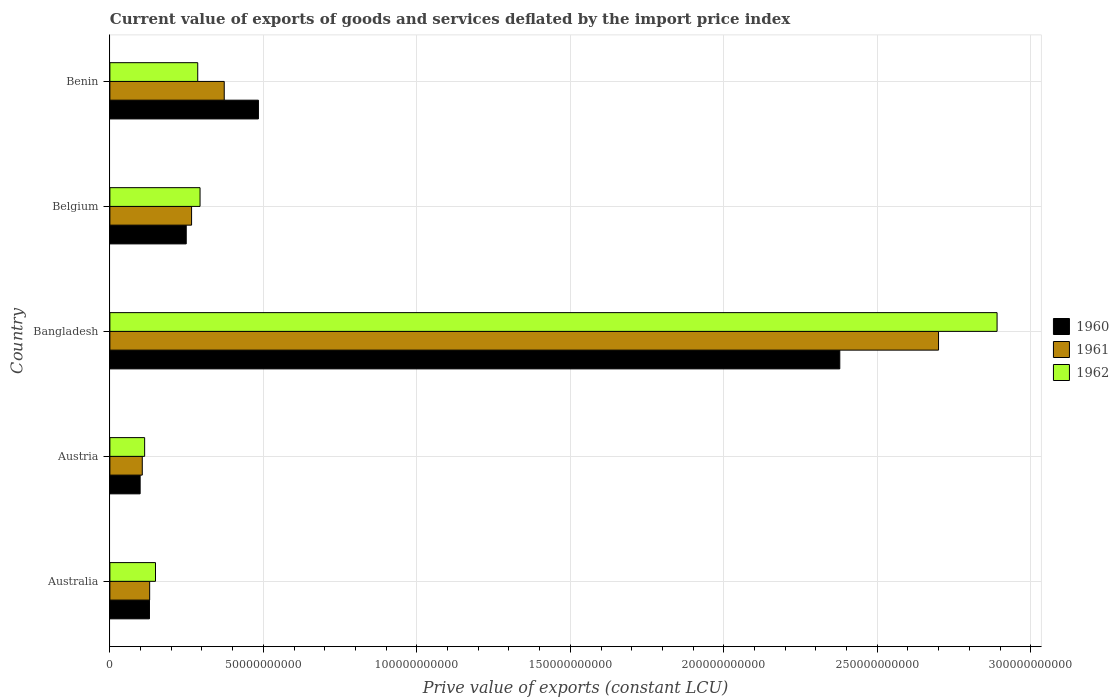How many bars are there on the 4th tick from the top?
Keep it short and to the point. 3. What is the label of the 1st group of bars from the top?
Make the answer very short. Benin. In how many cases, is the number of bars for a given country not equal to the number of legend labels?
Offer a terse response. 0. What is the prive value of exports in 1960 in Benin?
Your answer should be compact. 4.84e+1. Across all countries, what is the maximum prive value of exports in 1961?
Make the answer very short. 2.70e+11. Across all countries, what is the minimum prive value of exports in 1960?
Your response must be concise. 9.86e+09. In which country was the prive value of exports in 1961 minimum?
Provide a short and direct response. Austria. What is the total prive value of exports in 1960 in the graph?
Provide a succinct answer. 3.34e+11. What is the difference between the prive value of exports in 1961 in Austria and that in Bangladesh?
Your answer should be very brief. -2.59e+11. What is the difference between the prive value of exports in 1962 in Benin and the prive value of exports in 1960 in Belgium?
Your answer should be compact. 3.75e+09. What is the average prive value of exports in 1961 per country?
Give a very brief answer. 7.15e+1. What is the difference between the prive value of exports in 1962 and prive value of exports in 1961 in Belgium?
Your answer should be very brief. 2.76e+09. In how many countries, is the prive value of exports in 1960 greater than 70000000000 LCU?
Keep it short and to the point. 1. What is the ratio of the prive value of exports in 1960 in Bangladesh to that in Benin?
Offer a terse response. 4.91. Is the difference between the prive value of exports in 1962 in Austria and Bangladesh greater than the difference between the prive value of exports in 1961 in Austria and Bangladesh?
Provide a short and direct response. No. What is the difference between the highest and the second highest prive value of exports in 1960?
Offer a very short reply. 1.89e+11. What is the difference between the highest and the lowest prive value of exports in 1962?
Provide a succinct answer. 2.78e+11. What does the 1st bar from the bottom in Belgium represents?
Offer a terse response. 1960. Is it the case that in every country, the sum of the prive value of exports in 1960 and prive value of exports in 1962 is greater than the prive value of exports in 1961?
Keep it short and to the point. Yes. How many bars are there?
Your answer should be compact. 15. How many countries are there in the graph?
Offer a terse response. 5. Are the values on the major ticks of X-axis written in scientific E-notation?
Provide a succinct answer. No. Does the graph contain any zero values?
Make the answer very short. No. Where does the legend appear in the graph?
Provide a succinct answer. Center right. What is the title of the graph?
Offer a terse response. Current value of exports of goods and services deflated by the import price index. What is the label or title of the X-axis?
Make the answer very short. Prive value of exports (constant LCU). What is the Prive value of exports (constant LCU) of 1960 in Australia?
Your answer should be compact. 1.29e+1. What is the Prive value of exports (constant LCU) of 1961 in Australia?
Ensure brevity in your answer.  1.30e+1. What is the Prive value of exports (constant LCU) of 1962 in Australia?
Keep it short and to the point. 1.49e+1. What is the Prive value of exports (constant LCU) in 1960 in Austria?
Keep it short and to the point. 9.86e+09. What is the Prive value of exports (constant LCU) in 1961 in Austria?
Provide a succinct answer. 1.06e+1. What is the Prive value of exports (constant LCU) of 1962 in Austria?
Give a very brief answer. 1.13e+1. What is the Prive value of exports (constant LCU) of 1960 in Bangladesh?
Keep it short and to the point. 2.38e+11. What is the Prive value of exports (constant LCU) of 1961 in Bangladesh?
Give a very brief answer. 2.70e+11. What is the Prive value of exports (constant LCU) of 1962 in Bangladesh?
Provide a succinct answer. 2.89e+11. What is the Prive value of exports (constant LCU) of 1960 in Belgium?
Your answer should be compact. 2.49e+1. What is the Prive value of exports (constant LCU) of 1961 in Belgium?
Your response must be concise. 2.66e+1. What is the Prive value of exports (constant LCU) in 1962 in Belgium?
Keep it short and to the point. 2.94e+1. What is the Prive value of exports (constant LCU) in 1960 in Benin?
Your answer should be very brief. 4.84e+1. What is the Prive value of exports (constant LCU) of 1961 in Benin?
Provide a succinct answer. 3.73e+1. What is the Prive value of exports (constant LCU) in 1962 in Benin?
Give a very brief answer. 2.86e+1. Across all countries, what is the maximum Prive value of exports (constant LCU) in 1960?
Give a very brief answer. 2.38e+11. Across all countries, what is the maximum Prive value of exports (constant LCU) in 1961?
Your answer should be compact. 2.70e+11. Across all countries, what is the maximum Prive value of exports (constant LCU) of 1962?
Give a very brief answer. 2.89e+11. Across all countries, what is the minimum Prive value of exports (constant LCU) of 1960?
Keep it short and to the point. 9.86e+09. Across all countries, what is the minimum Prive value of exports (constant LCU) in 1961?
Give a very brief answer. 1.06e+1. Across all countries, what is the minimum Prive value of exports (constant LCU) of 1962?
Your answer should be very brief. 1.13e+1. What is the total Prive value of exports (constant LCU) in 1960 in the graph?
Offer a very short reply. 3.34e+11. What is the total Prive value of exports (constant LCU) of 1961 in the graph?
Make the answer very short. 3.57e+11. What is the total Prive value of exports (constant LCU) of 1962 in the graph?
Ensure brevity in your answer.  3.73e+11. What is the difference between the Prive value of exports (constant LCU) in 1960 in Australia and that in Austria?
Provide a short and direct response. 3.04e+09. What is the difference between the Prive value of exports (constant LCU) in 1961 in Australia and that in Austria?
Give a very brief answer. 2.41e+09. What is the difference between the Prive value of exports (constant LCU) in 1962 in Australia and that in Austria?
Provide a succinct answer. 3.54e+09. What is the difference between the Prive value of exports (constant LCU) in 1960 in Australia and that in Bangladesh?
Give a very brief answer. -2.25e+11. What is the difference between the Prive value of exports (constant LCU) in 1961 in Australia and that in Bangladesh?
Your answer should be very brief. -2.57e+11. What is the difference between the Prive value of exports (constant LCU) in 1962 in Australia and that in Bangladesh?
Give a very brief answer. -2.74e+11. What is the difference between the Prive value of exports (constant LCU) of 1960 in Australia and that in Belgium?
Provide a short and direct response. -1.20e+1. What is the difference between the Prive value of exports (constant LCU) in 1961 in Australia and that in Belgium?
Provide a succinct answer. -1.37e+1. What is the difference between the Prive value of exports (constant LCU) of 1962 in Australia and that in Belgium?
Offer a terse response. -1.45e+1. What is the difference between the Prive value of exports (constant LCU) in 1960 in Australia and that in Benin?
Offer a terse response. -3.55e+1. What is the difference between the Prive value of exports (constant LCU) of 1961 in Australia and that in Benin?
Offer a terse response. -2.43e+1. What is the difference between the Prive value of exports (constant LCU) in 1962 in Australia and that in Benin?
Make the answer very short. -1.38e+1. What is the difference between the Prive value of exports (constant LCU) of 1960 in Austria and that in Bangladesh?
Ensure brevity in your answer.  -2.28e+11. What is the difference between the Prive value of exports (constant LCU) in 1961 in Austria and that in Bangladesh?
Your response must be concise. -2.59e+11. What is the difference between the Prive value of exports (constant LCU) in 1962 in Austria and that in Bangladesh?
Your response must be concise. -2.78e+11. What is the difference between the Prive value of exports (constant LCU) of 1960 in Austria and that in Belgium?
Provide a succinct answer. -1.50e+1. What is the difference between the Prive value of exports (constant LCU) of 1961 in Austria and that in Belgium?
Give a very brief answer. -1.61e+1. What is the difference between the Prive value of exports (constant LCU) of 1962 in Austria and that in Belgium?
Your answer should be compact. -1.81e+1. What is the difference between the Prive value of exports (constant LCU) of 1960 in Austria and that in Benin?
Give a very brief answer. -3.85e+1. What is the difference between the Prive value of exports (constant LCU) of 1961 in Austria and that in Benin?
Ensure brevity in your answer.  -2.67e+1. What is the difference between the Prive value of exports (constant LCU) in 1962 in Austria and that in Benin?
Offer a terse response. -1.73e+1. What is the difference between the Prive value of exports (constant LCU) in 1960 in Bangladesh and that in Belgium?
Provide a succinct answer. 2.13e+11. What is the difference between the Prive value of exports (constant LCU) of 1961 in Bangladesh and that in Belgium?
Your answer should be compact. 2.43e+11. What is the difference between the Prive value of exports (constant LCU) of 1962 in Bangladesh and that in Belgium?
Your answer should be very brief. 2.60e+11. What is the difference between the Prive value of exports (constant LCU) of 1960 in Bangladesh and that in Benin?
Provide a short and direct response. 1.89e+11. What is the difference between the Prive value of exports (constant LCU) in 1961 in Bangladesh and that in Benin?
Provide a short and direct response. 2.33e+11. What is the difference between the Prive value of exports (constant LCU) in 1962 in Bangladesh and that in Benin?
Ensure brevity in your answer.  2.60e+11. What is the difference between the Prive value of exports (constant LCU) of 1960 in Belgium and that in Benin?
Provide a short and direct response. -2.35e+1. What is the difference between the Prive value of exports (constant LCU) in 1961 in Belgium and that in Benin?
Your answer should be very brief. -1.06e+1. What is the difference between the Prive value of exports (constant LCU) of 1962 in Belgium and that in Benin?
Give a very brief answer. 7.58e+08. What is the difference between the Prive value of exports (constant LCU) in 1960 in Australia and the Prive value of exports (constant LCU) in 1961 in Austria?
Offer a terse response. 2.34e+09. What is the difference between the Prive value of exports (constant LCU) of 1960 in Australia and the Prive value of exports (constant LCU) of 1962 in Austria?
Your answer should be compact. 1.57e+09. What is the difference between the Prive value of exports (constant LCU) in 1961 in Australia and the Prive value of exports (constant LCU) in 1962 in Austria?
Offer a very short reply. 1.64e+09. What is the difference between the Prive value of exports (constant LCU) in 1960 in Australia and the Prive value of exports (constant LCU) in 1961 in Bangladesh?
Keep it short and to the point. -2.57e+11. What is the difference between the Prive value of exports (constant LCU) of 1960 in Australia and the Prive value of exports (constant LCU) of 1962 in Bangladesh?
Ensure brevity in your answer.  -2.76e+11. What is the difference between the Prive value of exports (constant LCU) of 1961 in Australia and the Prive value of exports (constant LCU) of 1962 in Bangladesh?
Give a very brief answer. -2.76e+11. What is the difference between the Prive value of exports (constant LCU) of 1960 in Australia and the Prive value of exports (constant LCU) of 1961 in Belgium?
Your response must be concise. -1.37e+1. What is the difference between the Prive value of exports (constant LCU) of 1960 in Australia and the Prive value of exports (constant LCU) of 1962 in Belgium?
Give a very brief answer. -1.65e+1. What is the difference between the Prive value of exports (constant LCU) of 1961 in Australia and the Prive value of exports (constant LCU) of 1962 in Belgium?
Your response must be concise. -1.64e+1. What is the difference between the Prive value of exports (constant LCU) in 1960 in Australia and the Prive value of exports (constant LCU) in 1961 in Benin?
Your response must be concise. -2.44e+1. What is the difference between the Prive value of exports (constant LCU) in 1960 in Australia and the Prive value of exports (constant LCU) in 1962 in Benin?
Keep it short and to the point. -1.57e+1. What is the difference between the Prive value of exports (constant LCU) in 1961 in Australia and the Prive value of exports (constant LCU) in 1962 in Benin?
Your answer should be compact. -1.57e+1. What is the difference between the Prive value of exports (constant LCU) in 1960 in Austria and the Prive value of exports (constant LCU) in 1961 in Bangladesh?
Offer a very short reply. -2.60e+11. What is the difference between the Prive value of exports (constant LCU) in 1960 in Austria and the Prive value of exports (constant LCU) in 1962 in Bangladesh?
Give a very brief answer. -2.79e+11. What is the difference between the Prive value of exports (constant LCU) of 1961 in Austria and the Prive value of exports (constant LCU) of 1962 in Bangladesh?
Keep it short and to the point. -2.78e+11. What is the difference between the Prive value of exports (constant LCU) in 1960 in Austria and the Prive value of exports (constant LCU) in 1961 in Belgium?
Your answer should be compact. -1.68e+1. What is the difference between the Prive value of exports (constant LCU) of 1960 in Austria and the Prive value of exports (constant LCU) of 1962 in Belgium?
Provide a succinct answer. -1.95e+1. What is the difference between the Prive value of exports (constant LCU) in 1961 in Austria and the Prive value of exports (constant LCU) in 1962 in Belgium?
Your answer should be very brief. -1.88e+1. What is the difference between the Prive value of exports (constant LCU) of 1960 in Austria and the Prive value of exports (constant LCU) of 1961 in Benin?
Your answer should be very brief. -2.74e+1. What is the difference between the Prive value of exports (constant LCU) of 1960 in Austria and the Prive value of exports (constant LCU) of 1962 in Benin?
Offer a very short reply. -1.88e+1. What is the difference between the Prive value of exports (constant LCU) of 1961 in Austria and the Prive value of exports (constant LCU) of 1962 in Benin?
Provide a succinct answer. -1.81e+1. What is the difference between the Prive value of exports (constant LCU) in 1960 in Bangladesh and the Prive value of exports (constant LCU) in 1961 in Belgium?
Your response must be concise. 2.11e+11. What is the difference between the Prive value of exports (constant LCU) in 1960 in Bangladesh and the Prive value of exports (constant LCU) in 1962 in Belgium?
Keep it short and to the point. 2.08e+11. What is the difference between the Prive value of exports (constant LCU) of 1961 in Bangladesh and the Prive value of exports (constant LCU) of 1962 in Belgium?
Give a very brief answer. 2.41e+11. What is the difference between the Prive value of exports (constant LCU) in 1960 in Bangladesh and the Prive value of exports (constant LCU) in 1961 in Benin?
Keep it short and to the point. 2.01e+11. What is the difference between the Prive value of exports (constant LCU) of 1960 in Bangladesh and the Prive value of exports (constant LCU) of 1962 in Benin?
Provide a short and direct response. 2.09e+11. What is the difference between the Prive value of exports (constant LCU) of 1961 in Bangladesh and the Prive value of exports (constant LCU) of 1962 in Benin?
Your answer should be very brief. 2.41e+11. What is the difference between the Prive value of exports (constant LCU) in 1960 in Belgium and the Prive value of exports (constant LCU) in 1961 in Benin?
Your response must be concise. -1.24e+1. What is the difference between the Prive value of exports (constant LCU) of 1960 in Belgium and the Prive value of exports (constant LCU) of 1962 in Benin?
Provide a succinct answer. -3.75e+09. What is the difference between the Prive value of exports (constant LCU) of 1961 in Belgium and the Prive value of exports (constant LCU) of 1962 in Benin?
Offer a very short reply. -2.00e+09. What is the average Prive value of exports (constant LCU) in 1960 per country?
Provide a succinct answer. 6.68e+1. What is the average Prive value of exports (constant LCU) of 1961 per country?
Offer a terse response. 7.15e+1. What is the average Prive value of exports (constant LCU) of 1962 per country?
Your response must be concise. 7.46e+1. What is the difference between the Prive value of exports (constant LCU) in 1960 and Prive value of exports (constant LCU) in 1961 in Australia?
Offer a terse response. -6.58e+07. What is the difference between the Prive value of exports (constant LCU) of 1960 and Prive value of exports (constant LCU) of 1962 in Australia?
Give a very brief answer. -1.96e+09. What is the difference between the Prive value of exports (constant LCU) in 1961 and Prive value of exports (constant LCU) in 1962 in Australia?
Your response must be concise. -1.90e+09. What is the difference between the Prive value of exports (constant LCU) of 1960 and Prive value of exports (constant LCU) of 1961 in Austria?
Provide a succinct answer. -6.95e+08. What is the difference between the Prive value of exports (constant LCU) in 1960 and Prive value of exports (constant LCU) in 1962 in Austria?
Provide a succinct answer. -1.46e+09. What is the difference between the Prive value of exports (constant LCU) in 1961 and Prive value of exports (constant LCU) in 1962 in Austria?
Your answer should be compact. -7.67e+08. What is the difference between the Prive value of exports (constant LCU) of 1960 and Prive value of exports (constant LCU) of 1961 in Bangladesh?
Your response must be concise. -3.22e+1. What is the difference between the Prive value of exports (constant LCU) of 1960 and Prive value of exports (constant LCU) of 1962 in Bangladesh?
Provide a short and direct response. -5.12e+1. What is the difference between the Prive value of exports (constant LCU) of 1961 and Prive value of exports (constant LCU) of 1962 in Bangladesh?
Your response must be concise. -1.91e+1. What is the difference between the Prive value of exports (constant LCU) of 1960 and Prive value of exports (constant LCU) of 1961 in Belgium?
Keep it short and to the point. -1.74e+09. What is the difference between the Prive value of exports (constant LCU) in 1960 and Prive value of exports (constant LCU) in 1962 in Belgium?
Provide a short and direct response. -4.50e+09. What is the difference between the Prive value of exports (constant LCU) in 1961 and Prive value of exports (constant LCU) in 1962 in Belgium?
Make the answer very short. -2.76e+09. What is the difference between the Prive value of exports (constant LCU) of 1960 and Prive value of exports (constant LCU) of 1961 in Benin?
Provide a succinct answer. 1.11e+1. What is the difference between the Prive value of exports (constant LCU) of 1960 and Prive value of exports (constant LCU) of 1962 in Benin?
Your answer should be compact. 1.98e+1. What is the difference between the Prive value of exports (constant LCU) in 1961 and Prive value of exports (constant LCU) in 1962 in Benin?
Your answer should be very brief. 8.64e+09. What is the ratio of the Prive value of exports (constant LCU) in 1960 in Australia to that in Austria?
Your answer should be compact. 1.31. What is the ratio of the Prive value of exports (constant LCU) of 1961 in Australia to that in Austria?
Your response must be concise. 1.23. What is the ratio of the Prive value of exports (constant LCU) in 1962 in Australia to that in Austria?
Offer a very short reply. 1.31. What is the ratio of the Prive value of exports (constant LCU) of 1960 in Australia to that in Bangladesh?
Your answer should be very brief. 0.05. What is the ratio of the Prive value of exports (constant LCU) of 1961 in Australia to that in Bangladesh?
Provide a succinct answer. 0.05. What is the ratio of the Prive value of exports (constant LCU) in 1962 in Australia to that in Bangladesh?
Offer a terse response. 0.05. What is the ratio of the Prive value of exports (constant LCU) in 1960 in Australia to that in Belgium?
Provide a succinct answer. 0.52. What is the ratio of the Prive value of exports (constant LCU) in 1961 in Australia to that in Belgium?
Your answer should be compact. 0.49. What is the ratio of the Prive value of exports (constant LCU) in 1962 in Australia to that in Belgium?
Give a very brief answer. 0.51. What is the ratio of the Prive value of exports (constant LCU) in 1960 in Australia to that in Benin?
Offer a very short reply. 0.27. What is the ratio of the Prive value of exports (constant LCU) in 1961 in Australia to that in Benin?
Provide a short and direct response. 0.35. What is the ratio of the Prive value of exports (constant LCU) in 1962 in Australia to that in Benin?
Give a very brief answer. 0.52. What is the ratio of the Prive value of exports (constant LCU) of 1960 in Austria to that in Bangladesh?
Make the answer very short. 0.04. What is the ratio of the Prive value of exports (constant LCU) in 1961 in Austria to that in Bangladesh?
Give a very brief answer. 0.04. What is the ratio of the Prive value of exports (constant LCU) of 1962 in Austria to that in Bangladesh?
Provide a short and direct response. 0.04. What is the ratio of the Prive value of exports (constant LCU) of 1960 in Austria to that in Belgium?
Offer a very short reply. 0.4. What is the ratio of the Prive value of exports (constant LCU) of 1961 in Austria to that in Belgium?
Give a very brief answer. 0.4. What is the ratio of the Prive value of exports (constant LCU) in 1962 in Austria to that in Belgium?
Ensure brevity in your answer.  0.39. What is the ratio of the Prive value of exports (constant LCU) of 1960 in Austria to that in Benin?
Keep it short and to the point. 0.2. What is the ratio of the Prive value of exports (constant LCU) of 1961 in Austria to that in Benin?
Keep it short and to the point. 0.28. What is the ratio of the Prive value of exports (constant LCU) in 1962 in Austria to that in Benin?
Your answer should be compact. 0.4. What is the ratio of the Prive value of exports (constant LCU) of 1960 in Bangladesh to that in Belgium?
Offer a very short reply. 9.56. What is the ratio of the Prive value of exports (constant LCU) in 1961 in Bangladesh to that in Belgium?
Your response must be concise. 10.14. What is the ratio of the Prive value of exports (constant LCU) in 1962 in Bangladesh to that in Belgium?
Keep it short and to the point. 9.84. What is the ratio of the Prive value of exports (constant LCU) in 1960 in Bangladesh to that in Benin?
Keep it short and to the point. 4.91. What is the ratio of the Prive value of exports (constant LCU) of 1961 in Bangladesh to that in Benin?
Your answer should be very brief. 7.25. What is the ratio of the Prive value of exports (constant LCU) in 1962 in Bangladesh to that in Benin?
Offer a very short reply. 10.1. What is the ratio of the Prive value of exports (constant LCU) of 1960 in Belgium to that in Benin?
Make the answer very short. 0.51. What is the ratio of the Prive value of exports (constant LCU) of 1961 in Belgium to that in Benin?
Make the answer very short. 0.71. What is the ratio of the Prive value of exports (constant LCU) of 1962 in Belgium to that in Benin?
Provide a short and direct response. 1.03. What is the difference between the highest and the second highest Prive value of exports (constant LCU) of 1960?
Your answer should be very brief. 1.89e+11. What is the difference between the highest and the second highest Prive value of exports (constant LCU) of 1961?
Offer a very short reply. 2.33e+11. What is the difference between the highest and the second highest Prive value of exports (constant LCU) of 1962?
Provide a succinct answer. 2.60e+11. What is the difference between the highest and the lowest Prive value of exports (constant LCU) in 1960?
Offer a terse response. 2.28e+11. What is the difference between the highest and the lowest Prive value of exports (constant LCU) of 1961?
Your answer should be very brief. 2.59e+11. What is the difference between the highest and the lowest Prive value of exports (constant LCU) of 1962?
Make the answer very short. 2.78e+11. 